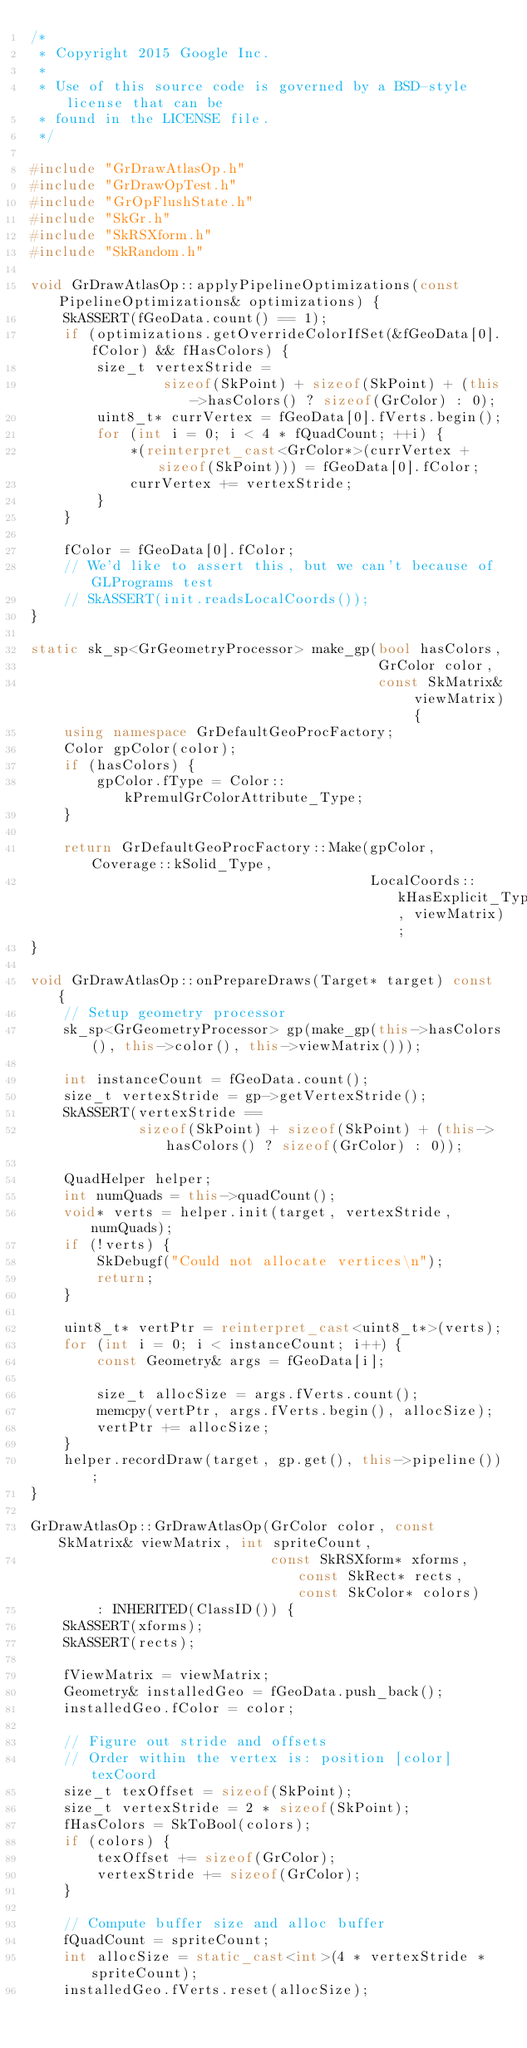Convert code to text. <code><loc_0><loc_0><loc_500><loc_500><_C++_>/*
 * Copyright 2015 Google Inc.
 *
 * Use of this source code is governed by a BSD-style license that can be
 * found in the LICENSE file.
 */

#include "GrDrawAtlasOp.h"
#include "GrDrawOpTest.h"
#include "GrOpFlushState.h"
#include "SkGr.h"
#include "SkRSXform.h"
#include "SkRandom.h"

void GrDrawAtlasOp::applyPipelineOptimizations(const PipelineOptimizations& optimizations) {
    SkASSERT(fGeoData.count() == 1);
    if (optimizations.getOverrideColorIfSet(&fGeoData[0].fColor) && fHasColors) {
        size_t vertexStride =
                sizeof(SkPoint) + sizeof(SkPoint) + (this->hasColors() ? sizeof(GrColor) : 0);
        uint8_t* currVertex = fGeoData[0].fVerts.begin();
        for (int i = 0; i < 4 * fQuadCount; ++i) {
            *(reinterpret_cast<GrColor*>(currVertex + sizeof(SkPoint))) = fGeoData[0].fColor;
            currVertex += vertexStride;
        }
    }

    fColor = fGeoData[0].fColor;
    // We'd like to assert this, but we can't because of GLPrograms test
    // SkASSERT(init.readsLocalCoords());
}

static sk_sp<GrGeometryProcessor> make_gp(bool hasColors,
                                          GrColor color,
                                          const SkMatrix& viewMatrix) {
    using namespace GrDefaultGeoProcFactory;
    Color gpColor(color);
    if (hasColors) {
        gpColor.fType = Color::kPremulGrColorAttribute_Type;
    }

    return GrDefaultGeoProcFactory::Make(gpColor, Coverage::kSolid_Type,
                                         LocalCoords::kHasExplicit_Type, viewMatrix);
}

void GrDrawAtlasOp::onPrepareDraws(Target* target) const {
    // Setup geometry processor
    sk_sp<GrGeometryProcessor> gp(make_gp(this->hasColors(), this->color(), this->viewMatrix()));

    int instanceCount = fGeoData.count();
    size_t vertexStride = gp->getVertexStride();
    SkASSERT(vertexStride ==
             sizeof(SkPoint) + sizeof(SkPoint) + (this->hasColors() ? sizeof(GrColor) : 0));

    QuadHelper helper;
    int numQuads = this->quadCount();
    void* verts = helper.init(target, vertexStride, numQuads);
    if (!verts) {
        SkDebugf("Could not allocate vertices\n");
        return;
    }

    uint8_t* vertPtr = reinterpret_cast<uint8_t*>(verts);
    for (int i = 0; i < instanceCount; i++) {
        const Geometry& args = fGeoData[i];

        size_t allocSize = args.fVerts.count();
        memcpy(vertPtr, args.fVerts.begin(), allocSize);
        vertPtr += allocSize;
    }
    helper.recordDraw(target, gp.get(), this->pipeline());
}

GrDrawAtlasOp::GrDrawAtlasOp(GrColor color, const SkMatrix& viewMatrix, int spriteCount,
                             const SkRSXform* xforms, const SkRect* rects, const SkColor* colors)
        : INHERITED(ClassID()) {
    SkASSERT(xforms);
    SkASSERT(rects);

    fViewMatrix = viewMatrix;
    Geometry& installedGeo = fGeoData.push_back();
    installedGeo.fColor = color;

    // Figure out stride and offsets
    // Order within the vertex is: position [color] texCoord
    size_t texOffset = sizeof(SkPoint);
    size_t vertexStride = 2 * sizeof(SkPoint);
    fHasColors = SkToBool(colors);
    if (colors) {
        texOffset += sizeof(GrColor);
        vertexStride += sizeof(GrColor);
    }

    // Compute buffer size and alloc buffer
    fQuadCount = spriteCount;
    int allocSize = static_cast<int>(4 * vertexStride * spriteCount);
    installedGeo.fVerts.reset(allocSize);</code> 